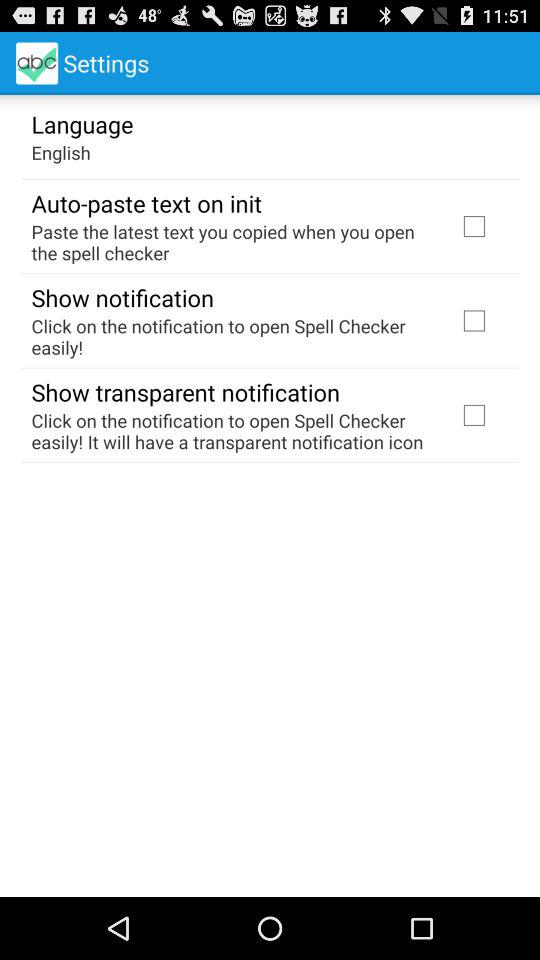What is the version number?
When the provided information is insufficient, respond with <no answer>. <no answer> 